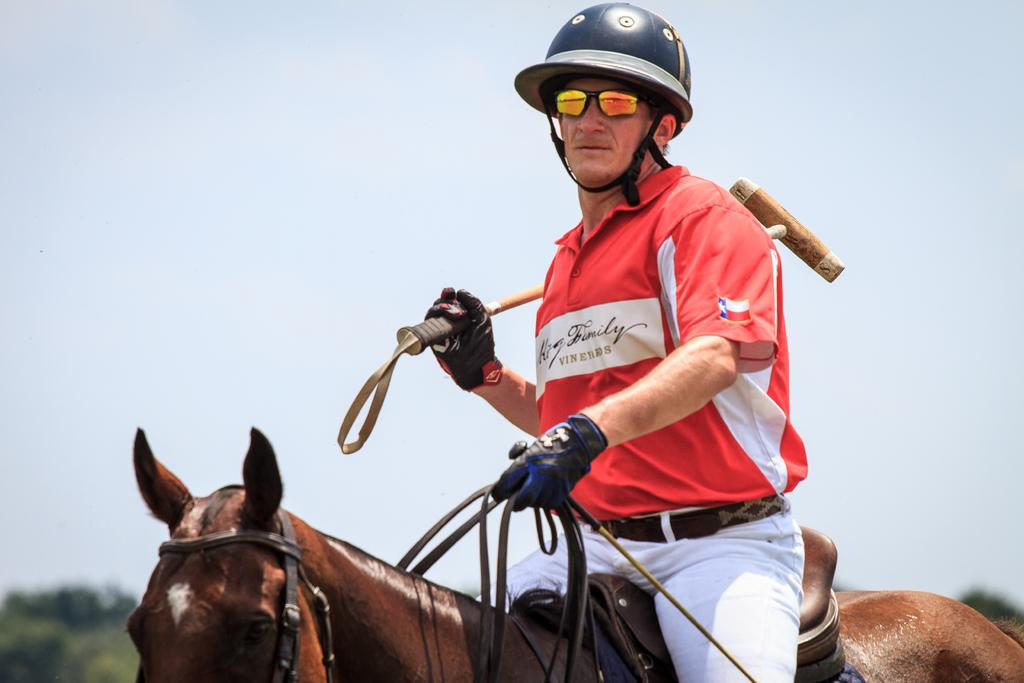What is the main subject in the foreground of the image? There is a man in the foreground of the image. What is the man doing in the image? The man is sitting on a horse. What can be seen in the background of the image? The background of the image is the sky. What type of soap is the man using to wash the metal bucket in the image? There is no soap, horse, or bucket present in the image. 